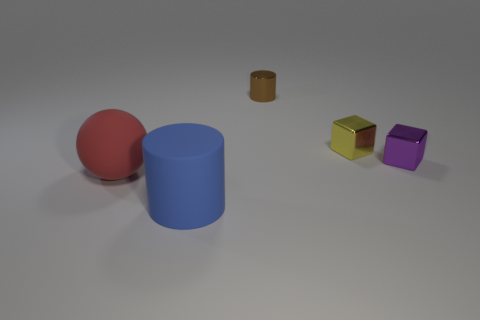Add 1 red things. How many objects exist? 6 Subtract all cylinders. How many objects are left? 3 Add 5 blue rubber cylinders. How many blue rubber cylinders are left? 6 Add 4 blue objects. How many blue objects exist? 5 Subtract 0 red cylinders. How many objects are left? 5 Subtract all large purple metallic cubes. Subtract all big matte spheres. How many objects are left? 4 